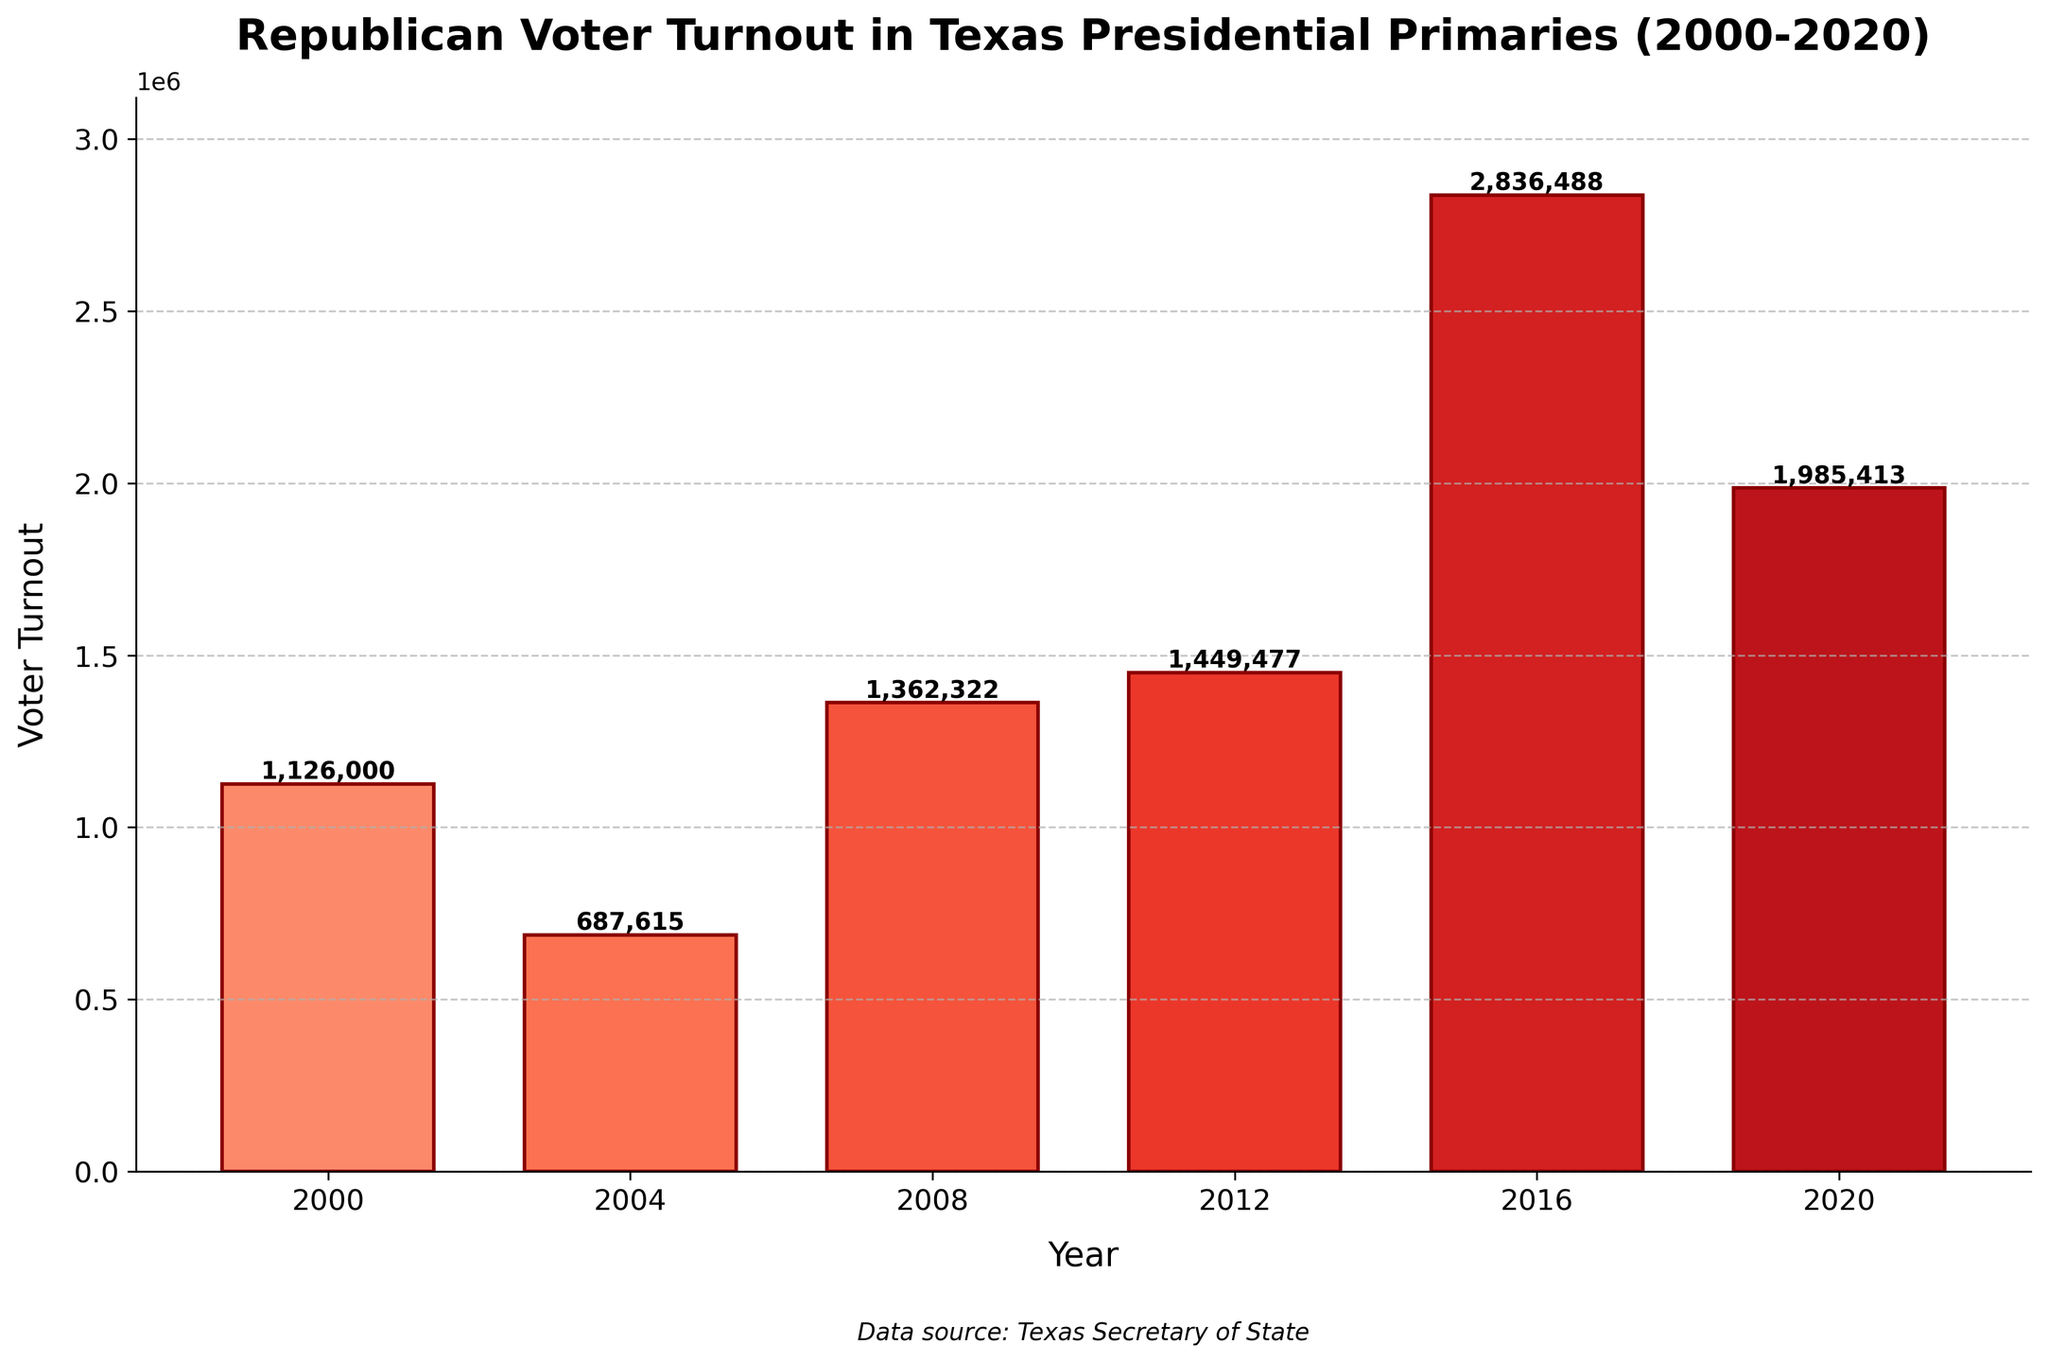What's the year with the highest Republican voter turnout? To find the highest voter turnout, look at the bar that extends the farthest along the y-axis. The year labeled at this bar is 2016.
Answer: 2016 What was the voter turnout in 2008? Locate the bar corresponding to the year 2008 and read the height label provided at the top of the bar, which shows the number of voters.
Answer: 1,362,322 How much did the voter turnout decrease from 2016 to 2020? Look at the bars for the years 2016 and 2020. The turnout for 2016 is 2,836,488, and for 2020 it is 1,985,413. Subtract the 2020 turnout from the 2016 turnout: 2,836,488 - 1,985,413 = 851,075.
Answer: 851,075 Which year had a lower turnout, 2004 or 2012, and by how much? Compare the heights of the bars for 2004 and 2012. The 2004 turnout is 687,615, and the 2012 turnout is 1,449,477. The difference is 1,449,477 - 687,615 = 761,862.
Answer: 2004, by 761,862 What's the average voter turnout across all the years shown? Sum the voter turnout numbers for all years: 1,126,000 + 687,615 + 1,362,322 + 1,449,477 + 2,836,488 + 1,985,413 = 9,447,315. Divide by the number of years: 9,447,315 / 6 ≈ 1,574,552.5.
Answer: 1,574,552.5 Which year had the second-highest voter turnout? Identify the bar with the second-highest height after the highest one. The highest is 2016, and the second highest is 2020 with 1,985,413.
Answer: 2020 What is the combined voter turnout for the years 2000 and 2008? Add the voter turnout numbers for 2000 and 2008: 1,126,000 + 1,362,322 = 2,488,322.
Answer: 2,488,322 What's the difference in voter turnout between the years with the highest and the lowest turnout? Identify the highest and lowest bars: 2016 with 2,836,488 and 2004 with 687,615, respectively. Subtract the lowest from the highest: 2,836,488 - 687,615 = 2,148,873.
Answer: 2,148,873 Between 2008 and 2012, which year saw an increase in voter turnout and by how much? Compare the bars for 2008 and 2012. The 2008 turnout is 1,362,322, and the 2012 turnout is 1,449,477. There is an increase of 1,449,477 - 1,362,322 = 87,155.
Answer: 2012, by 87,155 What was the median voter turnout across all the years? Order the voter turnout values: 687,615, 1,126,000, 1,362,322, 1,449,477, 1,985,413, 2,836,488. The median is the average of the middle two values: (1,362,322 + 1,449,477) / 2 = 1,405,899.5.
Answer: 1,405,899.5 